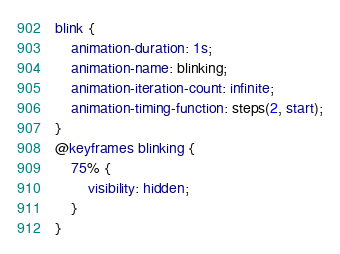Convert code to text. <code><loc_0><loc_0><loc_500><loc_500><_CSS_>blink {
    animation-duration: 1s;
    animation-name: blinking;
    animation-iteration-count: infinite;
    animation-timing-function: steps(2, start);
}
@keyframes blinking {
    75% {
        visibility: hidden;
    }
}
</code> 